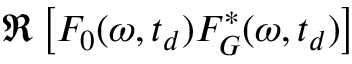Convert formula to latex. <formula><loc_0><loc_0><loc_500><loc_500>\Re \left [ F _ { 0 } ( \omega , t _ { d } ) F _ { G } ^ { * } ( \omega , t _ { d } ) \right ]</formula> 